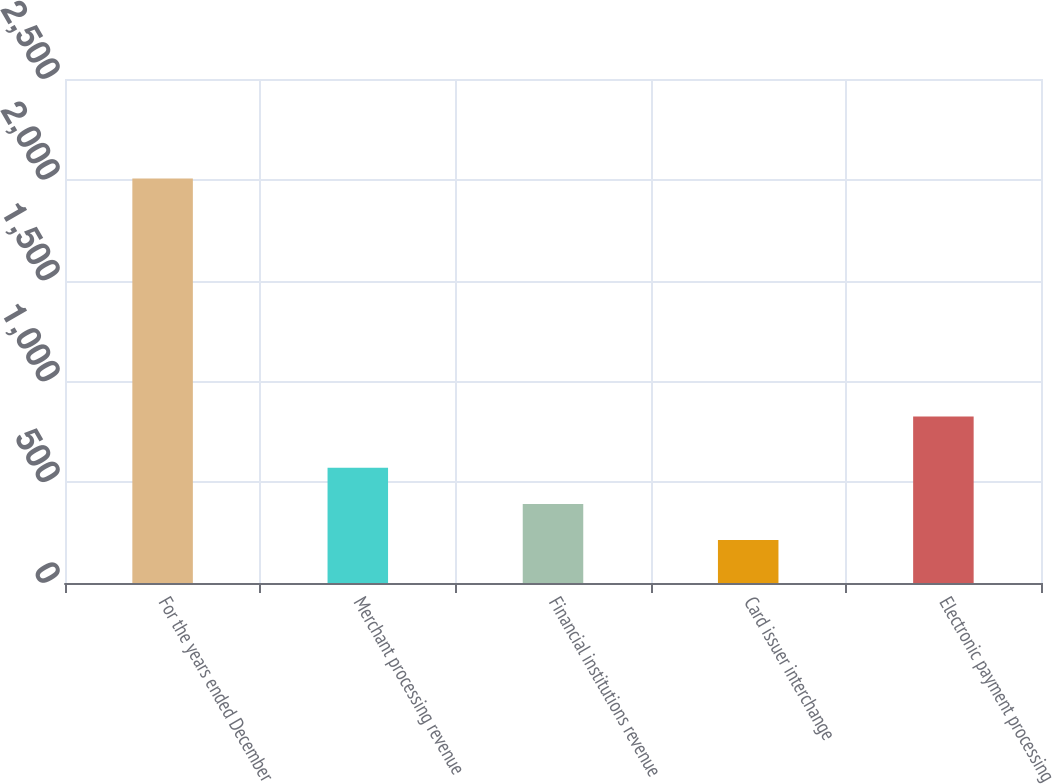Convert chart. <chart><loc_0><loc_0><loc_500><loc_500><bar_chart><fcel>For the years ended December<fcel>Merchant processing revenue<fcel>Financial institutions revenue<fcel>Card issuer interchange<fcel>Electronic payment processing<nl><fcel>2007<fcel>571.8<fcel>392.4<fcel>213<fcel>826<nl></chart> 